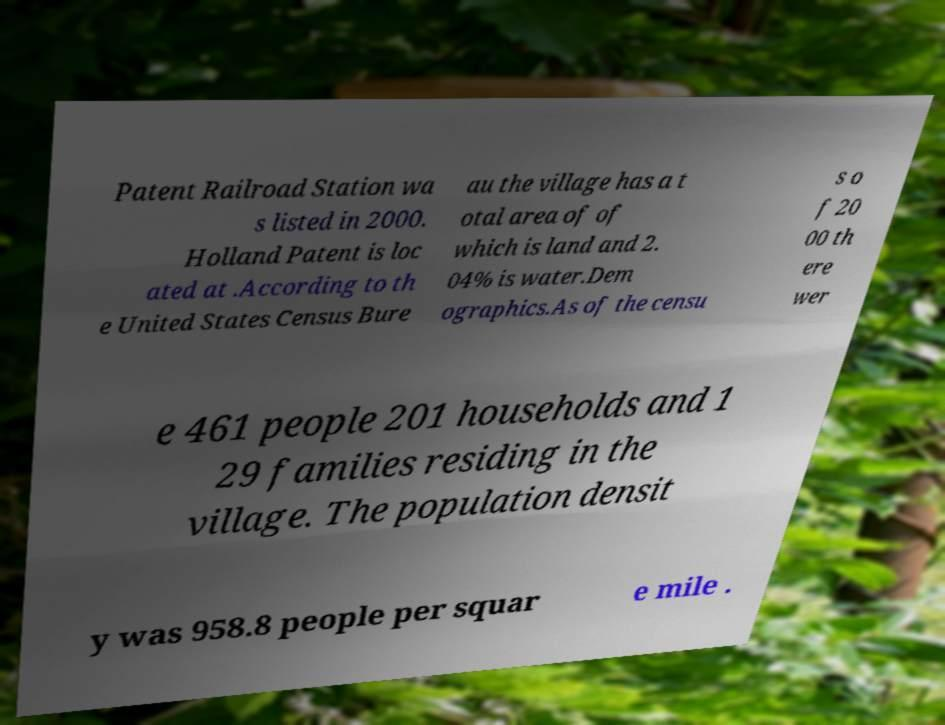Could you assist in decoding the text presented in this image and type it out clearly? Patent Railroad Station wa s listed in 2000. Holland Patent is loc ated at .According to th e United States Census Bure au the village has a t otal area of of which is land and 2. 04% is water.Dem ographics.As of the censu s o f 20 00 th ere wer e 461 people 201 households and 1 29 families residing in the village. The population densit y was 958.8 people per squar e mile . 